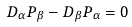<formula> <loc_0><loc_0><loc_500><loc_500>D _ { \alpha } P _ { \beta } - D _ { \beta } P _ { \alpha } = 0</formula> 